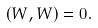Convert formula to latex. <formula><loc_0><loc_0><loc_500><loc_500>( W , W ) = 0 .</formula> 